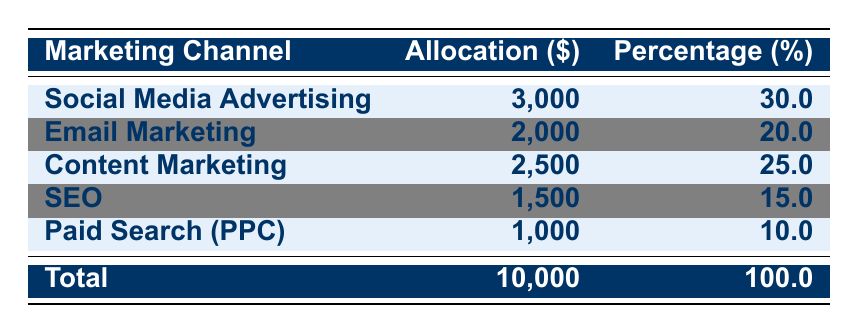What is the total marketing budget for 2023? The table states the total budget at the bottom row, which is clearly indicated as $10,000.
Answer: $10,000 How much is allocated to Social Media Advertising? The allocation for Social Media Advertising is highlighted in the table under the relevant channel, which shows $3,000.
Answer: $3,000 What percentage of the total budget is dedicated to Email Marketing? The table shows that Email Marketing is allocated $2,000, which is 20% of the total budget, as noted in the percentage column.
Answer: 20% Which marketing channel has the highest allocation? By comparing the allocations listed in the table, Social Media Advertising has the highest allocation with $3,000.
Answer: Social Media Advertising If I increase the Paid Search (PPC) budget by $500, what will be the new allocation? The original allocation for Paid Search (PPC) is $1,000. Adding $500 will give a new allocation of $1,000 + $500 = $1,500.
Answer: $1,500 How much more is allocated to Content Marketing than Paid Search (PPC)? Content Marketing has an allocation of $2,500 while Paid Search (PPC) has $1,000. The difference is $2,500 - $1,000 = $1,500.
Answer: $1,500 What is the total allocation for SEO activities (Keyword Research and Link Building)? The table shows that both Keyword Research and Link Building have an equal allocation of $750 each. Thus, the total is $750 + $750 = $1,500.
Answer: $1,500 What percentage of the marketing budget is spent on SEO (Search Engine Optimization)? The table indicates that SEO is allocated $1,500, which is 15% of the total budget. This value is directly shown in the percentage column.
Answer: 15% If you were to eliminate Social Media Advertising, what percentage of the total budget would remain? Removing Social Media Advertising ($3,000) leaves $10,000 - $3,000 = $7,000. The percentage of the remaining budget is ($7,000 / $10,000) * 100 = 70%.
Answer: 70% Is the allocation for Email Marketing greater than the allocation for SEO? The table shows Email Marketing at $2,000 and SEO at $1,500. Since $2,000 is greater than $1,500, the statement is true.
Answer: Yes How does the allocation for Content Marketing compare with the total for Email Marketing and SEO combined? Content Marketing is $2,500, while Email Marketing and SEO combined is $2,000 + $1,500 = $3,500. Since $2,500 is less than $3,500, Content Marketing is lower.
Answer: Lower 